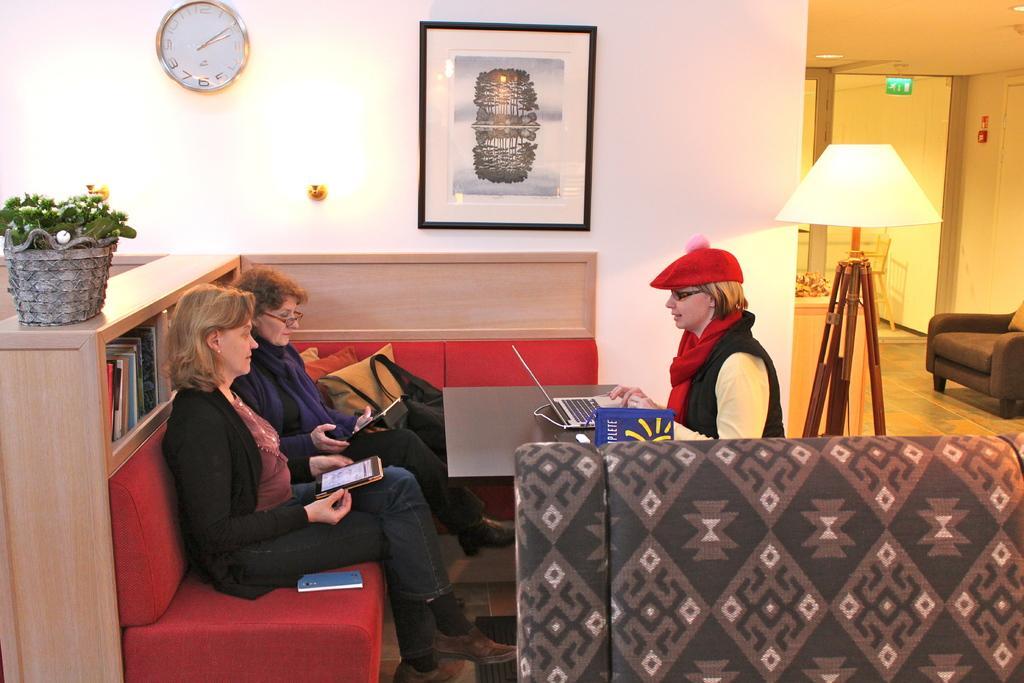Could you give a brief overview of what you see in this image? Here we can see three women sitting in front of a table present and the woman at the right is having a laptop in front of her and the both women who are sitting on the left are carrying a tablet in their hands and behind them there is a book rack and on that we can see a plant and on the wall we can see a clock and beside the clock we can see a portrait and at the right side we can see a lamp 